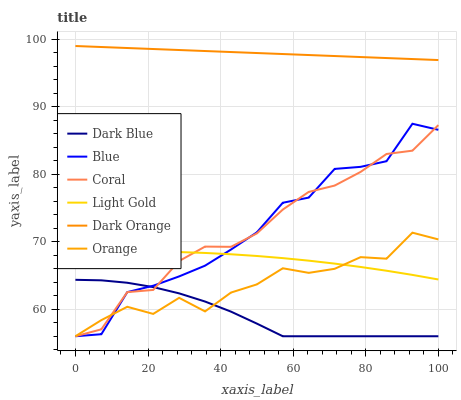Does Dark Blue have the minimum area under the curve?
Answer yes or no. Yes. Does Dark Orange have the maximum area under the curve?
Answer yes or no. Yes. Does Coral have the minimum area under the curve?
Answer yes or no. No. Does Coral have the maximum area under the curve?
Answer yes or no. No. Is Dark Orange the smoothest?
Answer yes or no. Yes. Is Blue the roughest?
Answer yes or no. Yes. Is Coral the smoothest?
Answer yes or no. No. Is Coral the roughest?
Answer yes or no. No. Does Blue have the lowest value?
Answer yes or no. Yes. Does Dark Orange have the lowest value?
Answer yes or no. No. Does Dark Orange have the highest value?
Answer yes or no. Yes. Does Coral have the highest value?
Answer yes or no. No. Is Blue less than Dark Orange?
Answer yes or no. Yes. Is Dark Orange greater than Light Gold?
Answer yes or no. Yes. Does Dark Blue intersect Blue?
Answer yes or no. Yes. Is Dark Blue less than Blue?
Answer yes or no. No. Is Dark Blue greater than Blue?
Answer yes or no. No. Does Blue intersect Dark Orange?
Answer yes or no. No. 